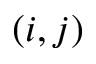<formula> <loc_0><loc_0><loc_500><loc_500>( i , j )</formula> 